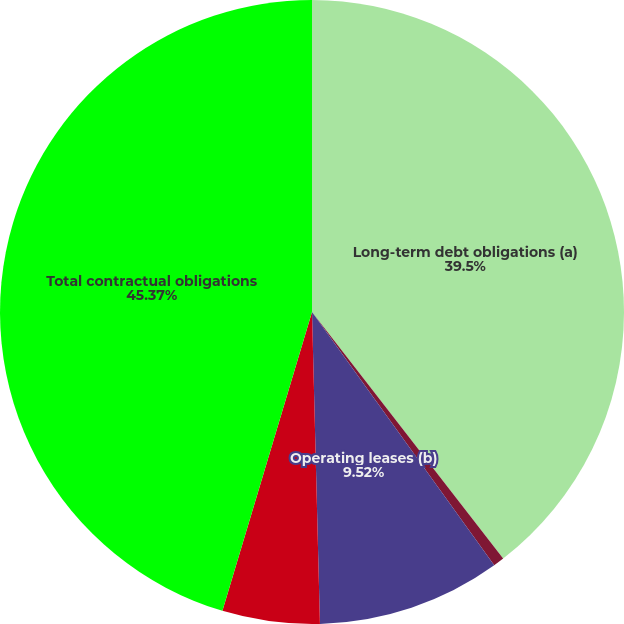<chart> <loc_0><loc_0><loc_500><loc_500><pie_chart><fcel>Long-term debt obligations (a)<fcel>Capital leases (b)<fcel>Operating leases (b)<fcel>Benefit plans and other (d)<fcel>Total contractual obligations<nl><fcel>39.5%<fcel>0.57%<fcel>9.52%<fcel>5.04%<fcel>45.36%<nl></chart> 